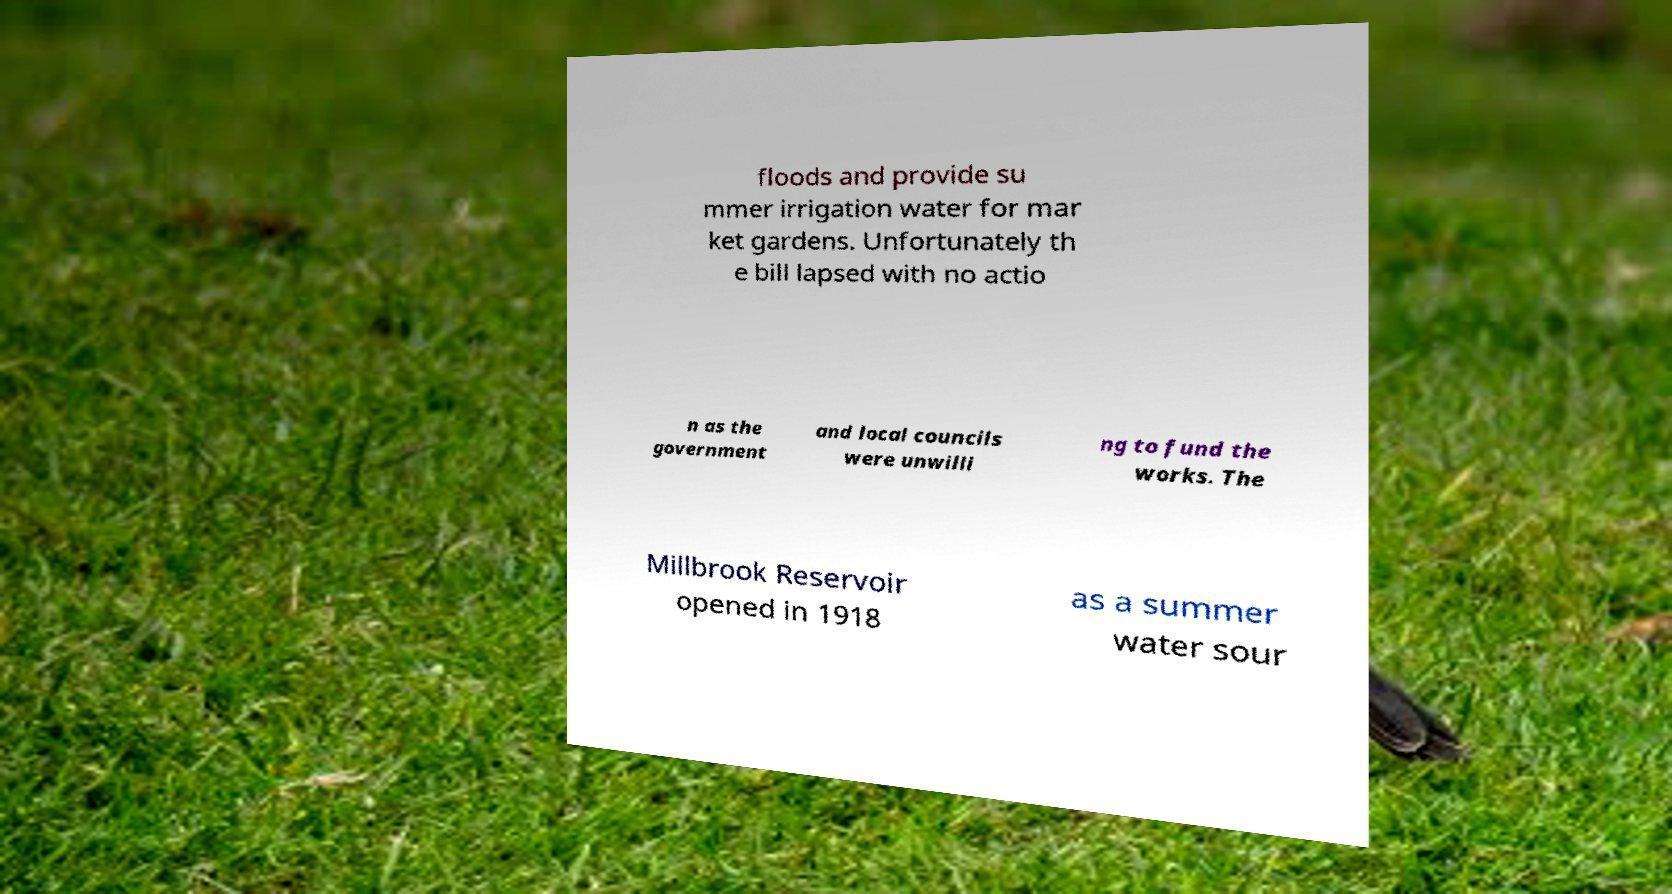Please read and relay the text visible in this image. What does it say? floods and provide su mmer irrigation water for mar ket gardens. Unfortunately th e bill lapsed with no actio n as the government and local councils were unwilli ng to fund the works. The Millbrook Reservoir opened in 1918 as a summer water sour 